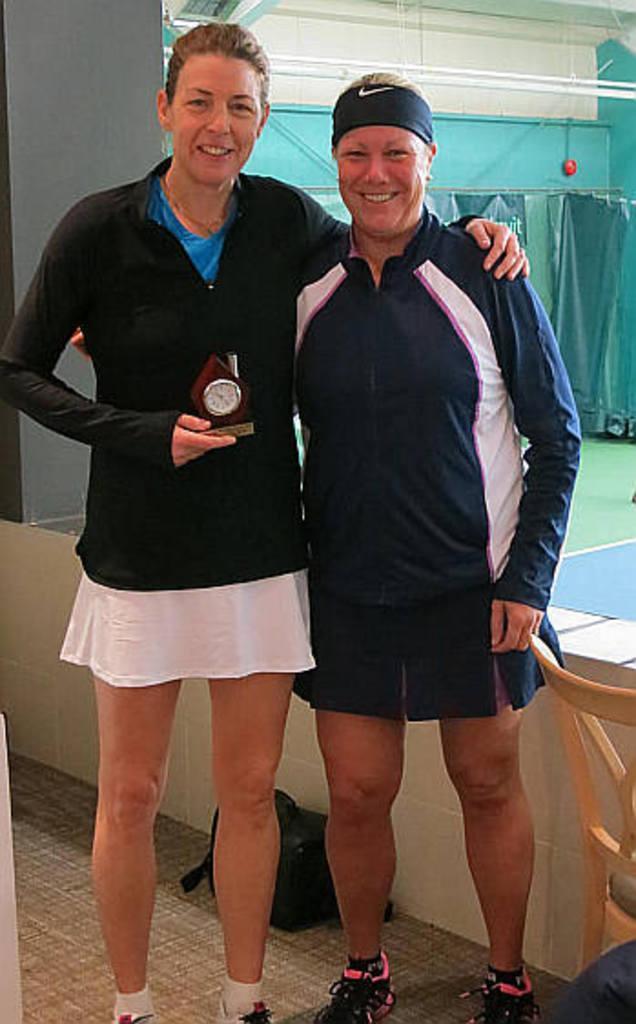Can you describe this image briefly? In the image there are two ladies standing. On the left side of the image there is a lady holding an object in the hand. Behind them there is a pillar, chair, bag on the floor and also there is a small wall. Behind them there are stands with curtains, walls and tube lights are hanging. 